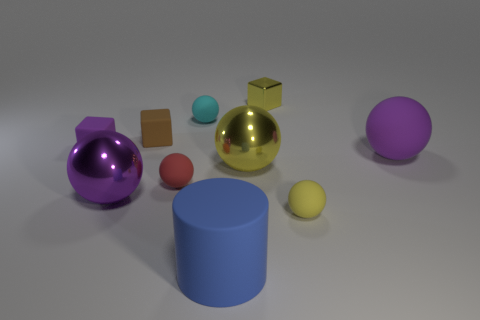Does the shiny thing that is in front of the large yellow metallic ball have the same color as the big rubber ball?
Ensure brevity in your answer.  Yes. Is the size of the red matte thing the same as the cyan ball?
Provide a succinct answer. Yes. What shape is the purple shiny thing that is the same size as the yellow shiny ball?
Provide a short and direct response. Sphere. There is a purple matte thing that is to the left of the cylinder; does it have the same size as the big blue rubber thing?
Give a very brief answer. No. There is a yellow thing that is the same size as the blue matte cylinder; what material is it?
Keep it short and to the point. Metal. There is a small sphere left of the small ball behind the tiny red matte sphere; are there any small cyan balls that are to the right of it?
Keep it short and to the point. Yes. Are there any other things that have the same shape as the yellow matte object?
Offer a terse response. Yes. Does the small matte sphere that is to the right of the tiny yellow cube have the same color as the matte object that is right of the yellow rubber ball?
Your answer should be compact. No. Is there a tiny ball?
Offer a very short reply. Yes. There is a big sphere that is the same color as the small metallic thing; what material is it?
Offer a terse response. Metal. 